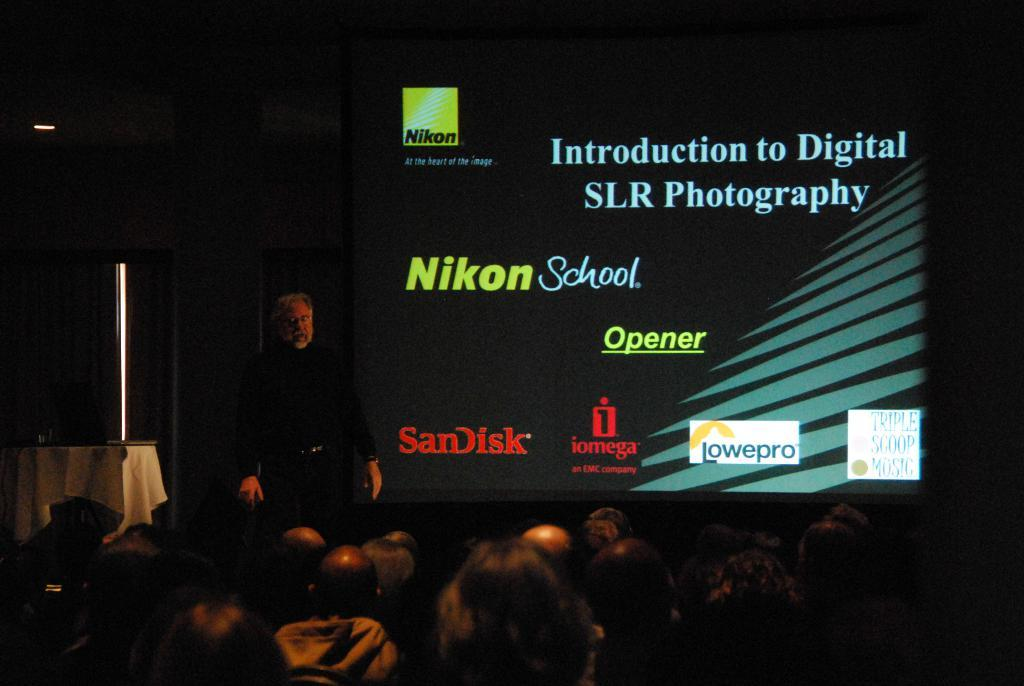Who or what is present in the image? There are people in the image. What can be seen on the screen in the background? There is text projected on a screen in the background. What is the source of light visible at the top of the image? The source of light visible at the top of the image is not specified in the facts provided. How many stars can be seen on the turkey in the image? There is no turkey or stars present in the image. 